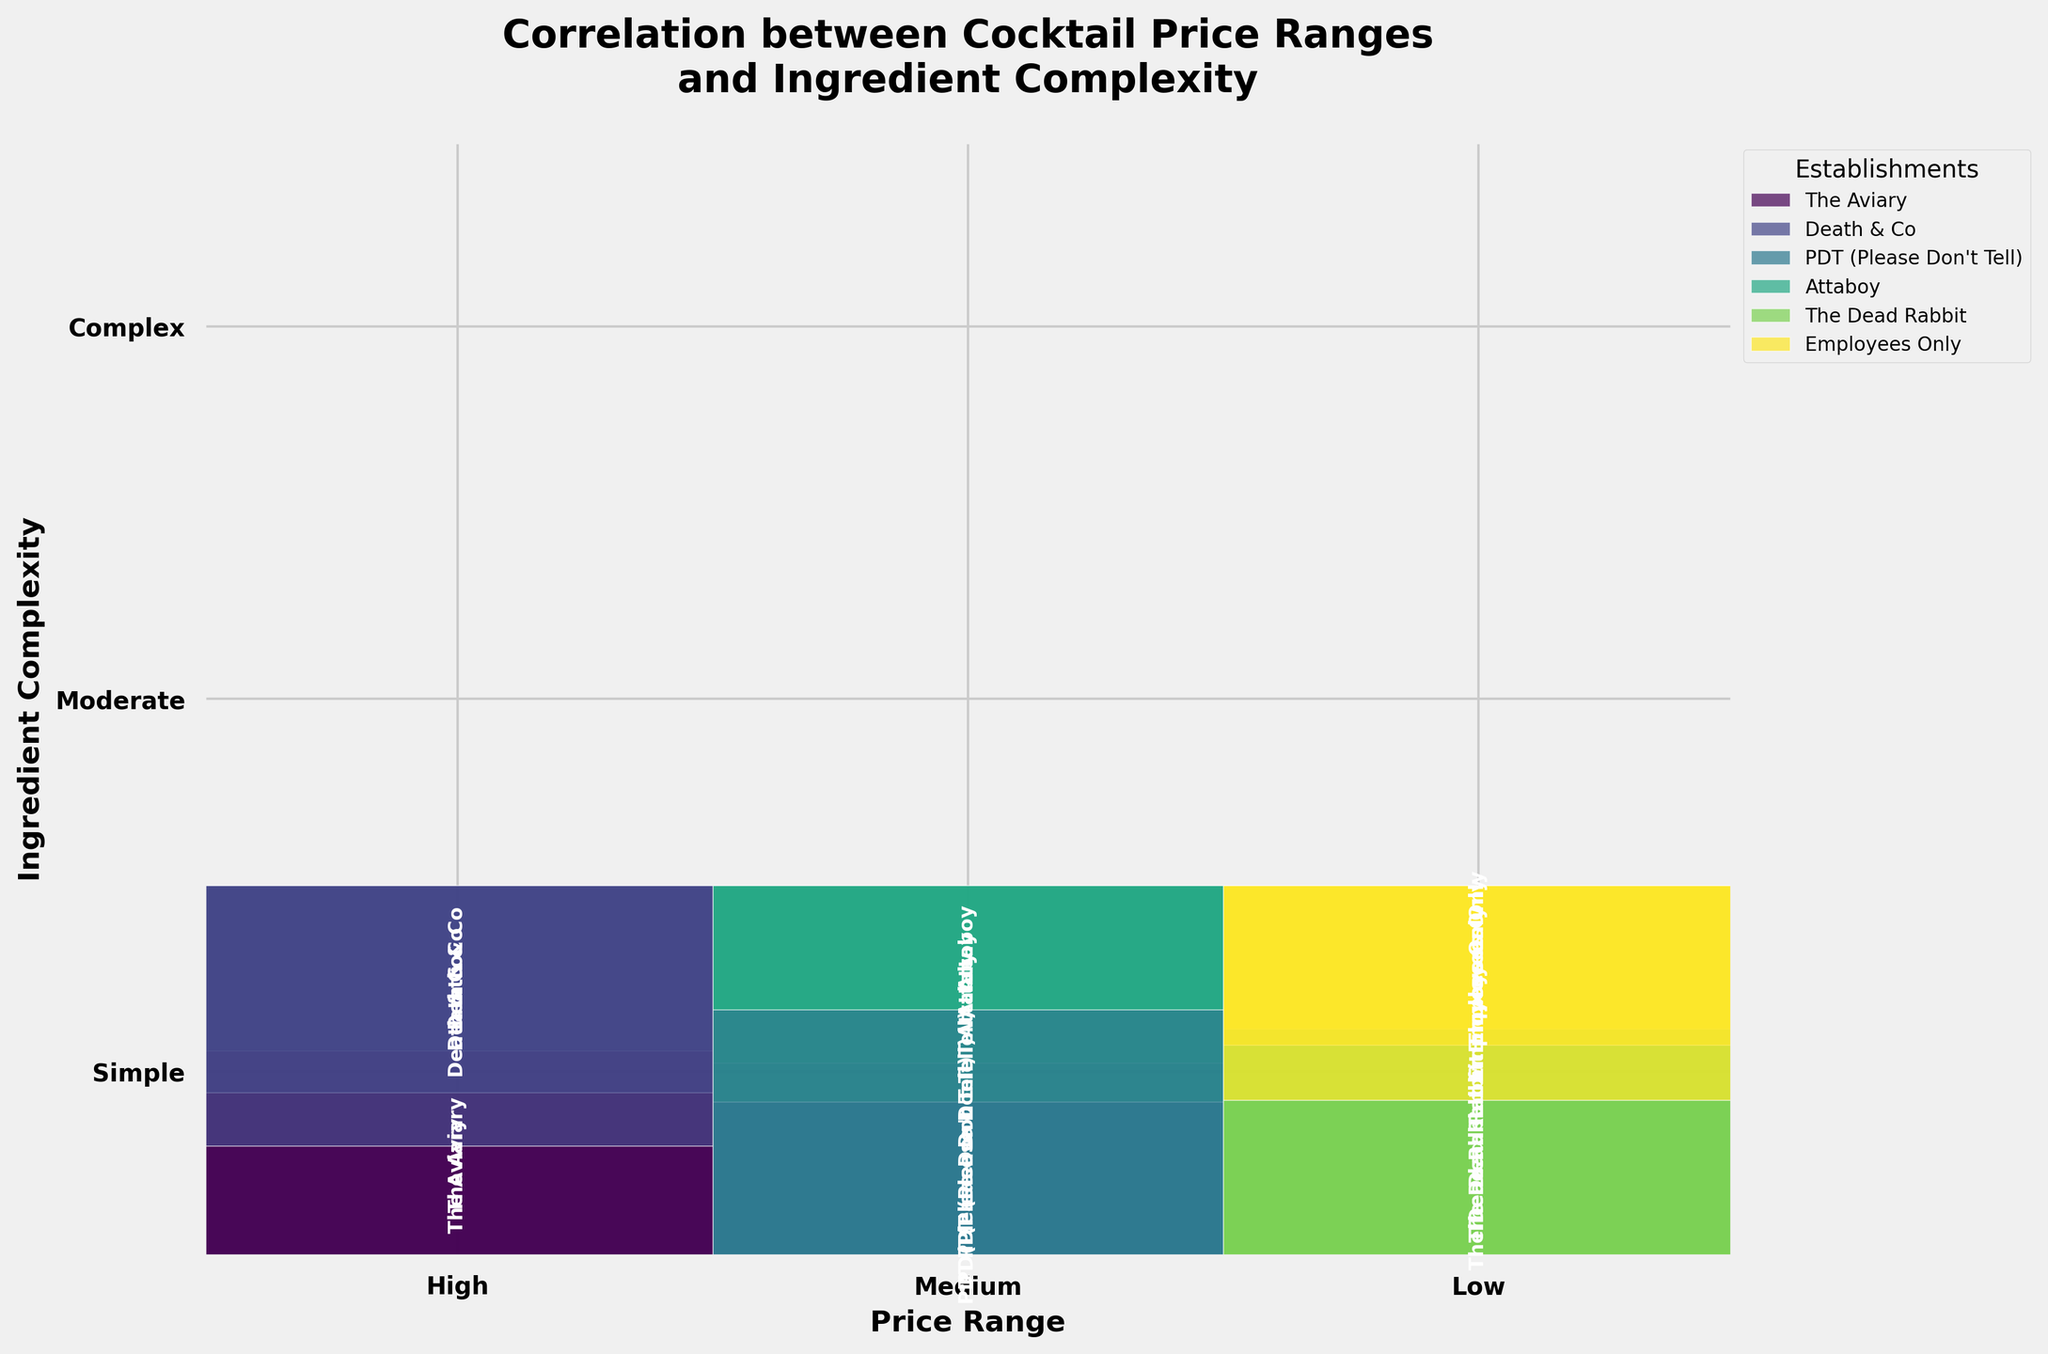What's the title of the plot? The title of the plot is typically found at the top of the figure. It is usually larger and bold to catch the viewer's attention.
Answer: Correlation between Cocktail Price Ranges and Ingredient Complexity How many price ranges are represented in the plot? Price ranges are represented along the x-axis. Each unique label on the x-axis corresponds to a different price range.
Answer: Three Which establishment has the highest frequency of cocktails in the "Low" price range with "Simple" ingredients? Look at the section of the Mosaic Plot corresponding to the "Low" price range and "Simple" ingredients. The establishment with the largest rectangle in this section has the highest frequency.
Answer: Employees Only Which establishment has the smallest share of "Medium" price range cocktails with "Moderate" ingredient complexity? Identify the section corresponding to "Medium" price range and "Moderate" complexity. Compare the size of rectangles for each establishment. The establishment with the smallest rectangle has the smallest share.
Answer: PDT (Please Don't Tell) How does the number of cocktails in the "High" price range with "Complex" ingredients compare between The Aviary and Death & Co? Compare the sizes of the rectangles for The Aviary and Death & Co in the "High" price range and "Complex" ingredients section.
Answer: The Aviary has a higher number than Death & Co What's the total frequency of cocktails in the "Medium" price range across all establishments? Sum the rectangle heights in the "Medium" price range section. Calculate the combined frequency values.
Answer: 100 Which ingredient complexity is most common in the "Low" price range across all establishments? Look at the "Low" price range sections and identify which ingredient complexity has the tallest combined rectangles for all establishments.
Answer: Simple Which establishment offers more cocktails with "Moderate" ingredient complexity, Attaboy or The Dead Rabbit? Compare the rectangle sizes for Attaboy and The Dead Rabbit in the "Moderate" ingredient complexity section.
Answer: Attaboy What can be inferred about the correlation between price range and ingredient complexity? Examine the overall distribution of rectangles. Determine whether higher price ranges are associated with more complex ingredients or not.
Answer: Higher prices generally correlate with more complex ingredients 